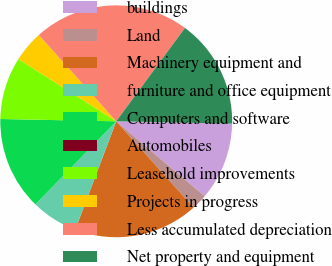<chart> <loc_0><loc_0><loc_500><loc_500><pie_chart><fcel>buildings<fcel>Land<fcel>Machinery equipment and<fcel>furniture and office equipment<fcel>Computers and software<fcel>Automobiles<fcel>Leasehold improvements<fcel>Projects in progress<fcel>Less accumulated depreciation<fcel>Net property and equipment<nl><fcel>10.87%<fcel>2.18%<fcel>17.39%<fcel>6.52%<fcel>13.04%<fcel>0.0%<fcel>8.7%<fcel>4.35%<fcel>21.74%<fcel>15.22%<nl></chart> 